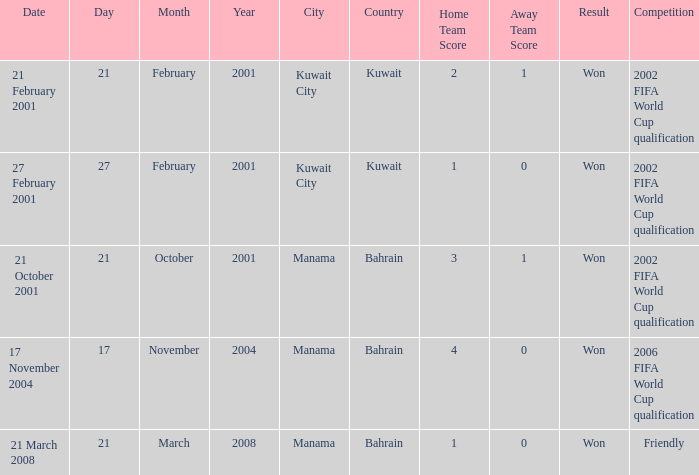On which date was the 2006 FIFA World Cup Qualification in Manama, Bahrain? 17 November 2004. 